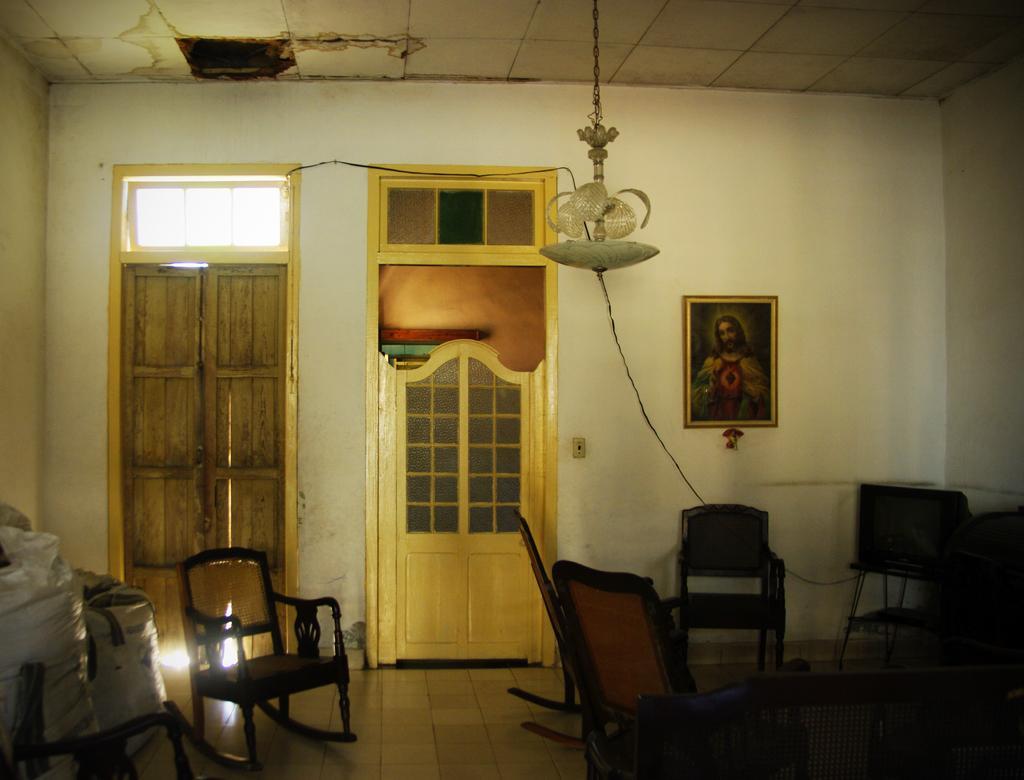Can you describe this image briefly? In this image few chairs are on the floor. Left side there are few bags on the floor. Right side there is a picture frame attached to the wall having doors. A chandelier is hanging from the roof. 